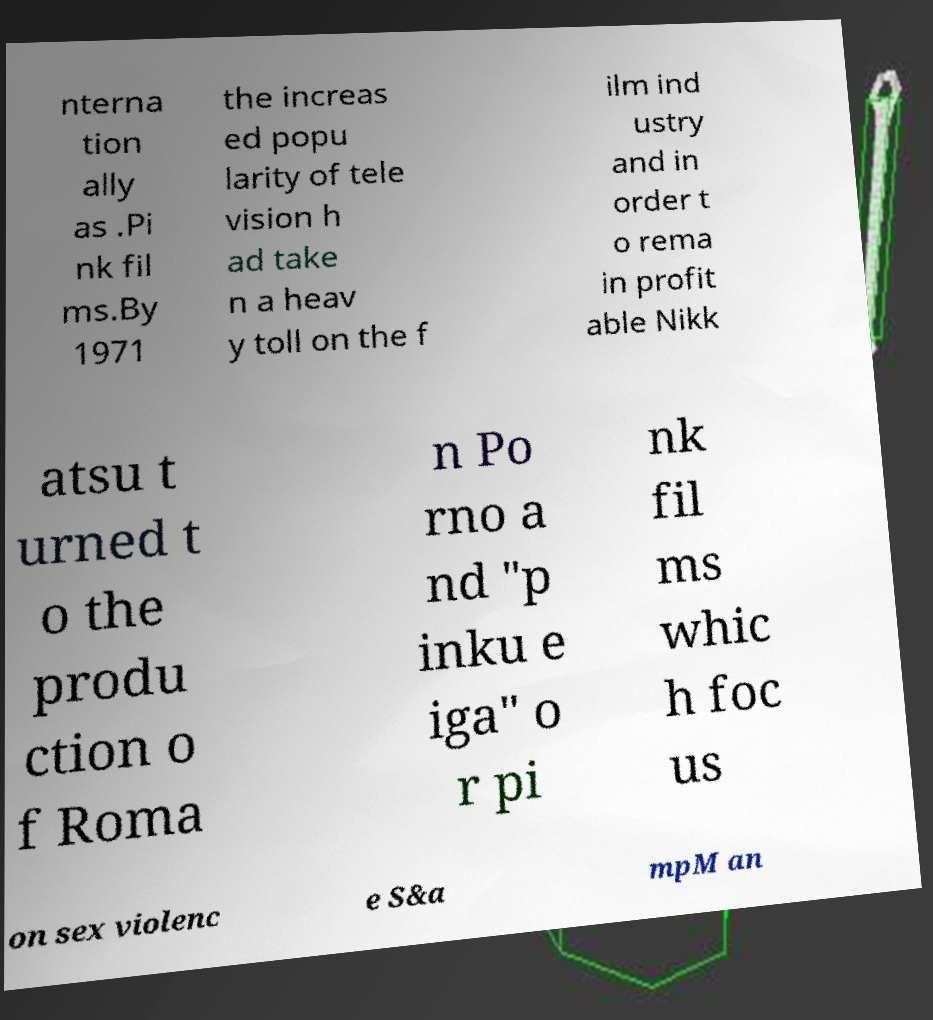I need the written content from this picture converted into text. Can you do that? nterna tion ally as .Pi nk fil ms.By 1971 the increas ed popu larity of tele vision h ad take n a heav y toll on the f ilm ind ustry and in order t o rema in profit able Nikk atsu t urned t o the produ ction o f Roma n Po rno a nd "p inku e iga" o r pi nk fil ms whic h foc us on sex violenc e S&a mpM an 